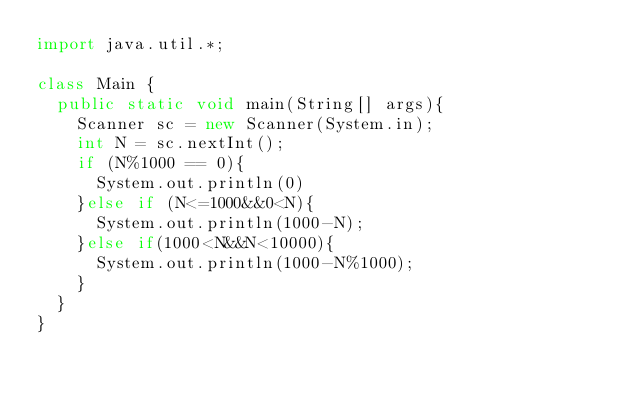Convert code to text. <code><loc_0><loc_0><loc_500><loc_500><_Java_>import java.util.*;
 
class Main {
  public static void main(String[] args){
    Scanner sc = new Scanner(System.in);
    int N = sc.nextInt();
    if (N%1000 == 0){
      System.out.println(0)
    }else if (N<=1000&&0<N){
      System.out.println(1000-N);
    }else if(1000<N&&N<10000){
      System.out.println(1000-N%1000);
    }
  }
}</code> 